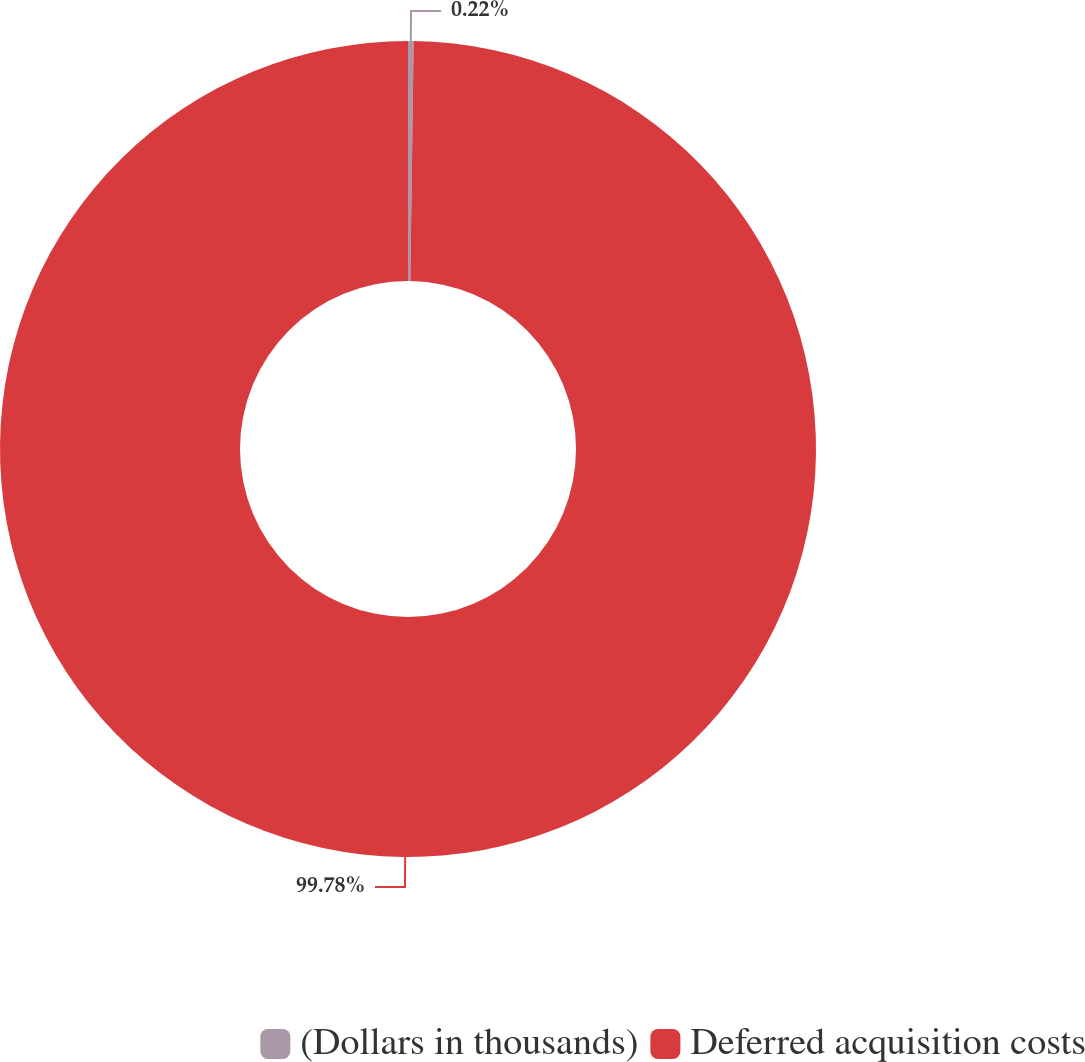Convert chart to OTSL. <chart><loc_0><loc_0><loc_500><loc_500><pie_chart><fcel>(Dollars in thousands)<fcel>Deferred acquisition costs<nl><fcel>0.22%<fcel>99.78%<nl></chart> 